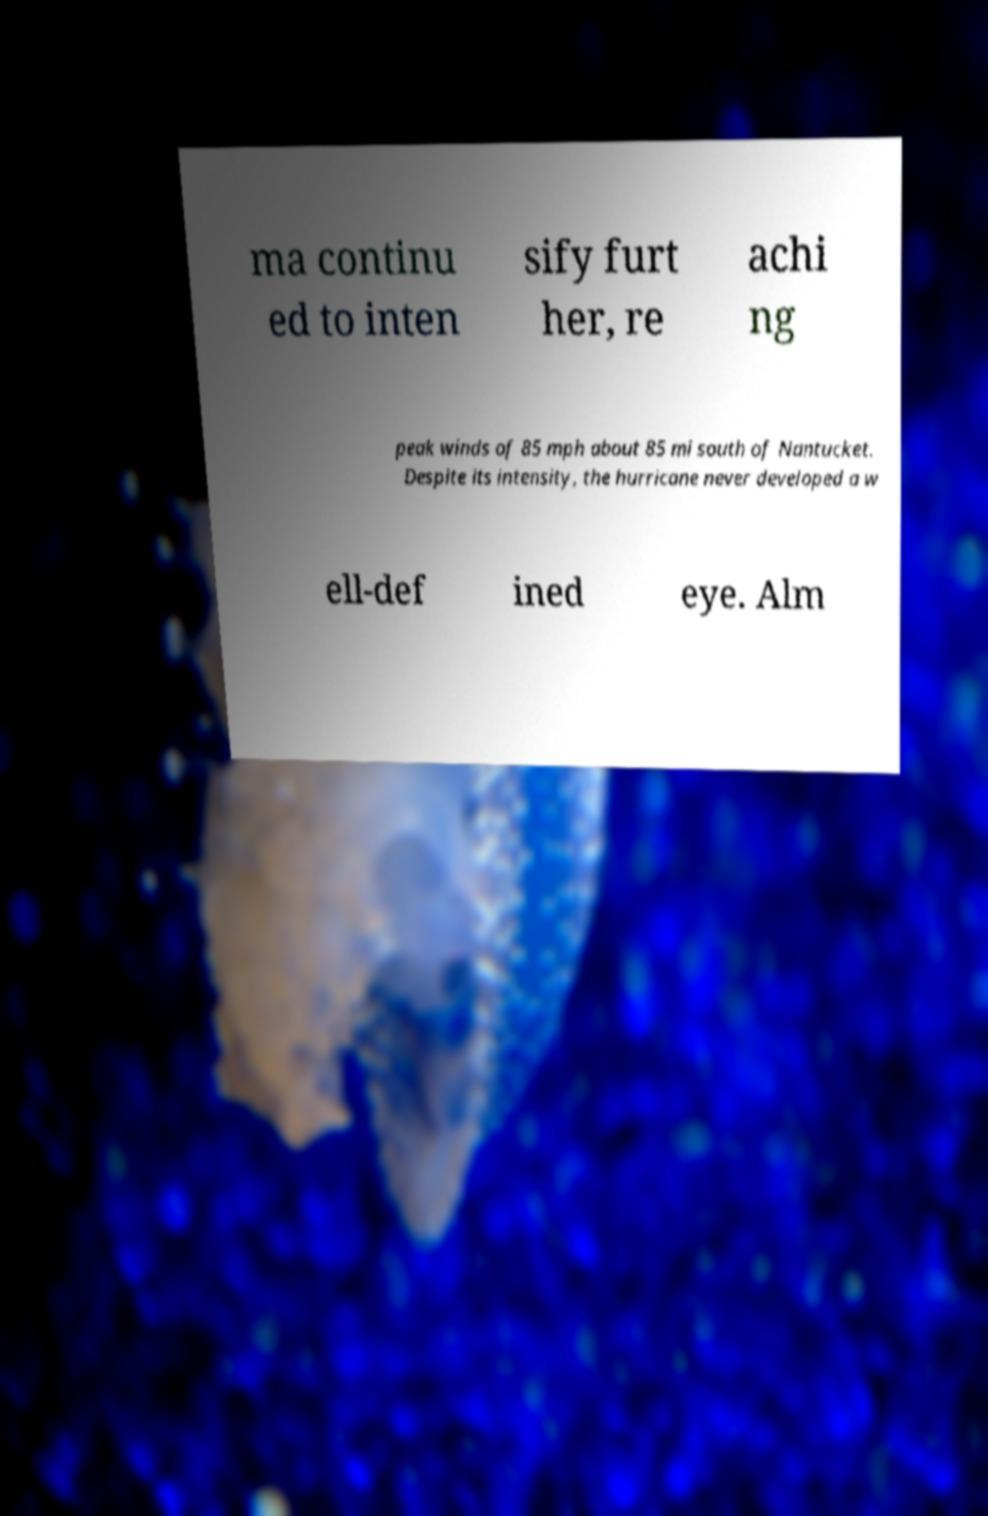There's text embedded in this image that I need extracted. Can you transcribe it verbatim? ma continu ed to inten sify furt her, re achi ng peak winds of 85 mph about 85 mi south of Nantucket. Despite its intensity, the hurricane never developed a w ell-def ined eye. Alm 